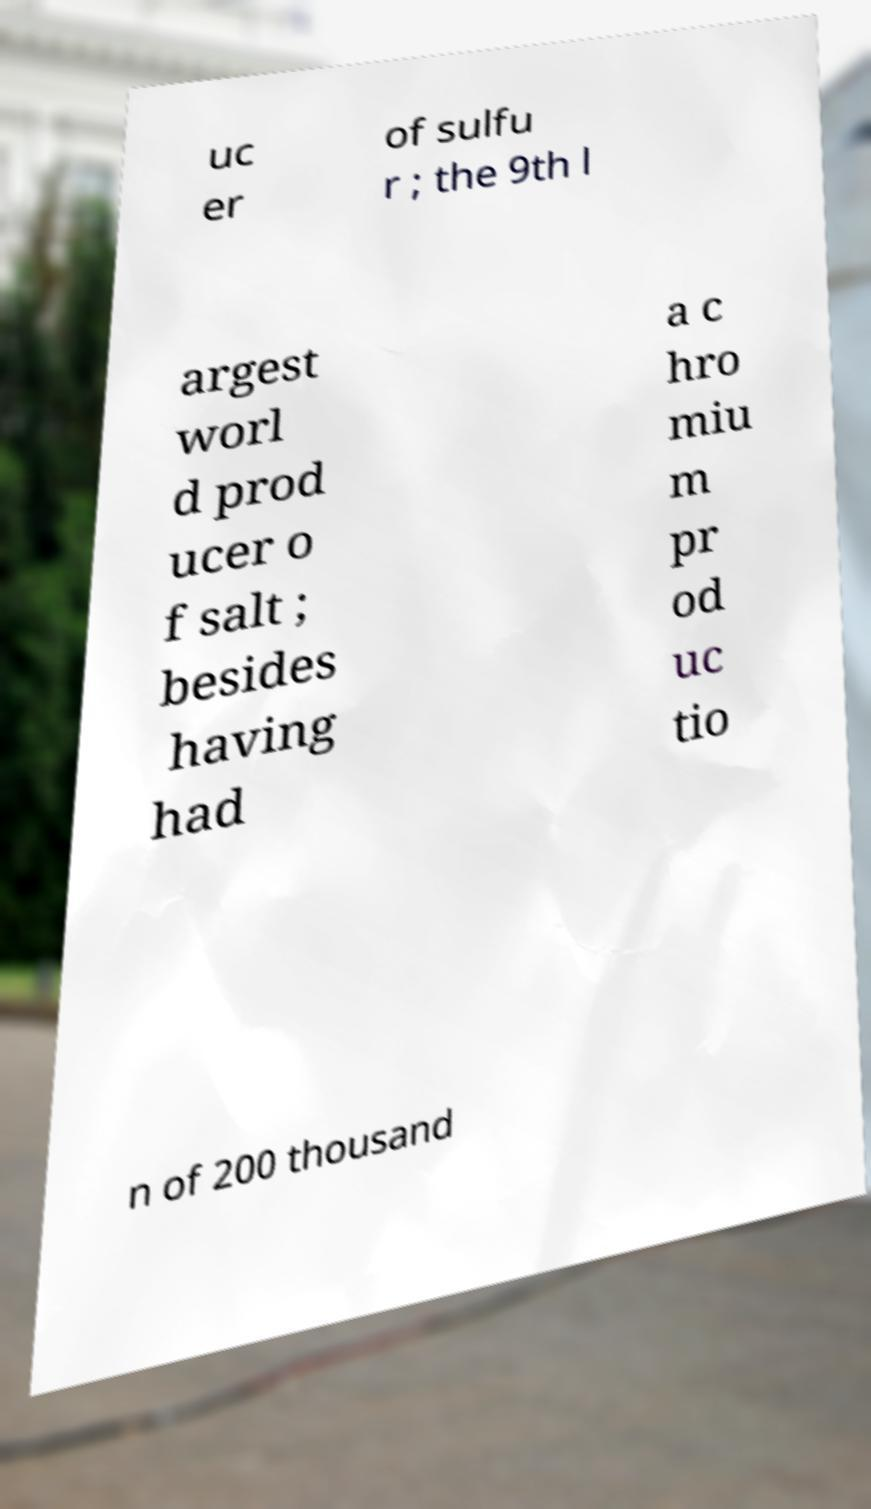Please read and relay the text visible in this image. What does it say? uc er of sulfu r ; the 9th l argest worl d prod ucer o f salt ; besides having had a c hro miu m pr od uc tio n of 200 thousand 